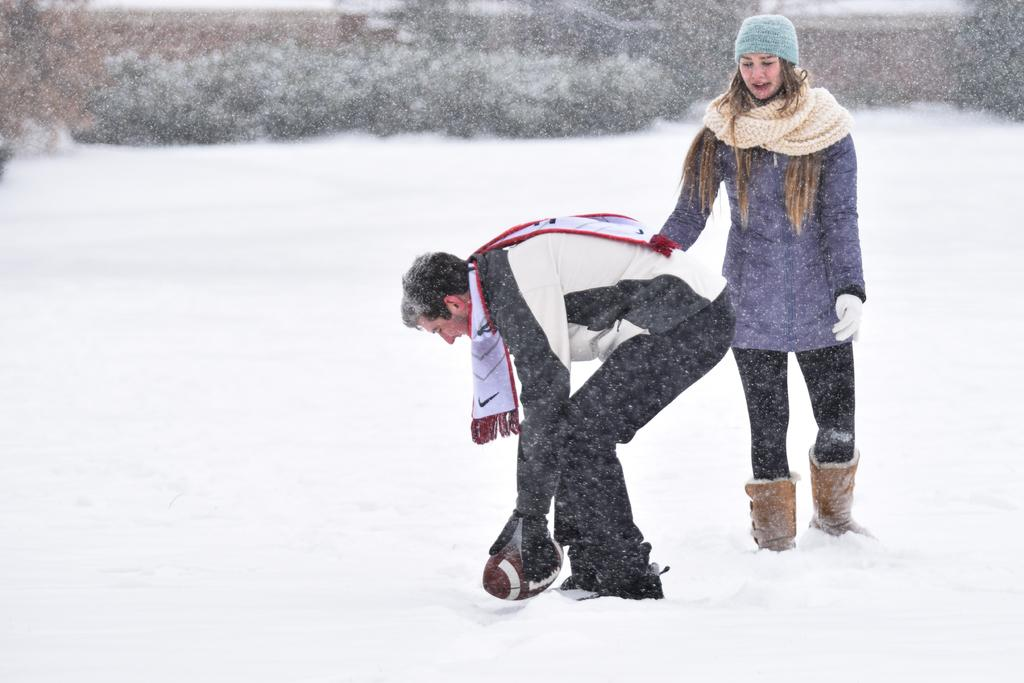How many people are in the image? There is a man and a woman in the image. What is the man holding in the image? The man is holding a ball. What is the man wearing in the image? The man is wearing a scarf. What is the condition of the land in the image? The land is covered with snow. What can be seen in the background of the image? There are plants in the background of the image. What type of things can be seen starting to whistle in the image? There are no things starting to whistle in the image. 